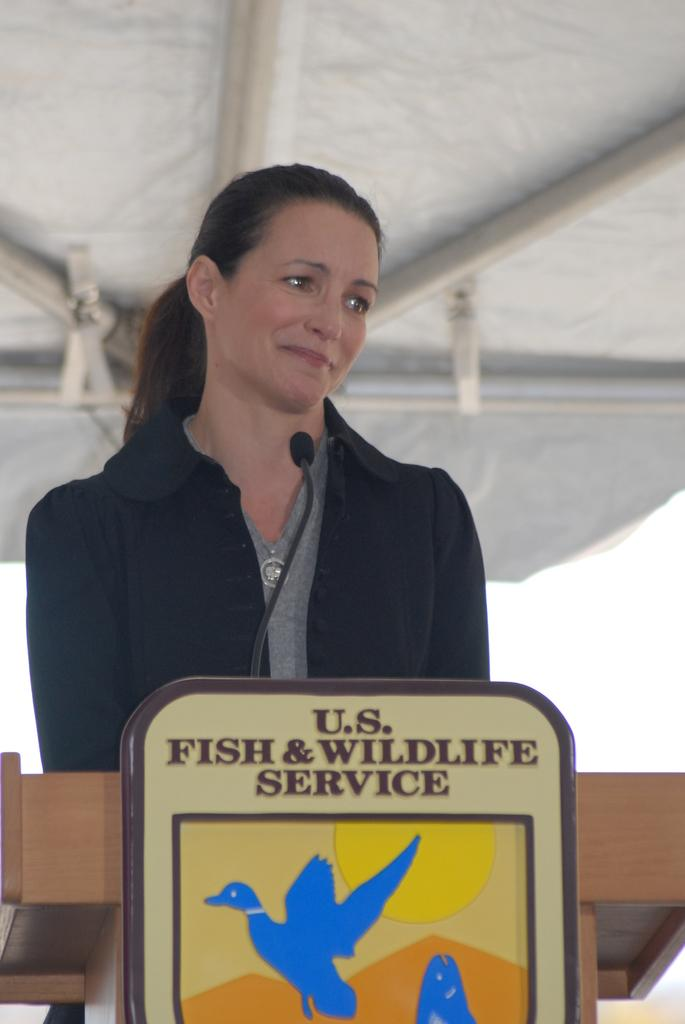Provide a one-sentence caption for the provided image. A woman standing behind a podium with a fish and wildlife service logo in front. 